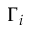<formula> <loc_0><loc_0><loc_500><loc_500>\Gamma _ { i }</formula> 